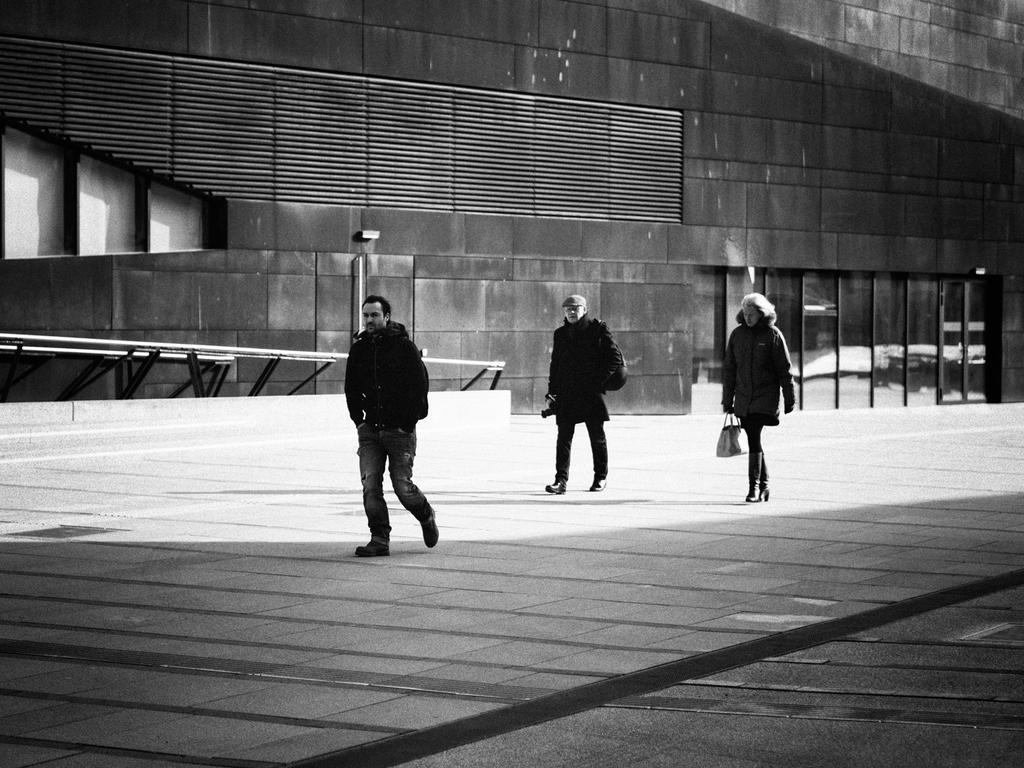Could you give a brief overview of what you see in this image? This is a black and white image. In this image we can see two men and a woman standing on the ground. In that the woman is holding a bag. On the backside we can see a building. 